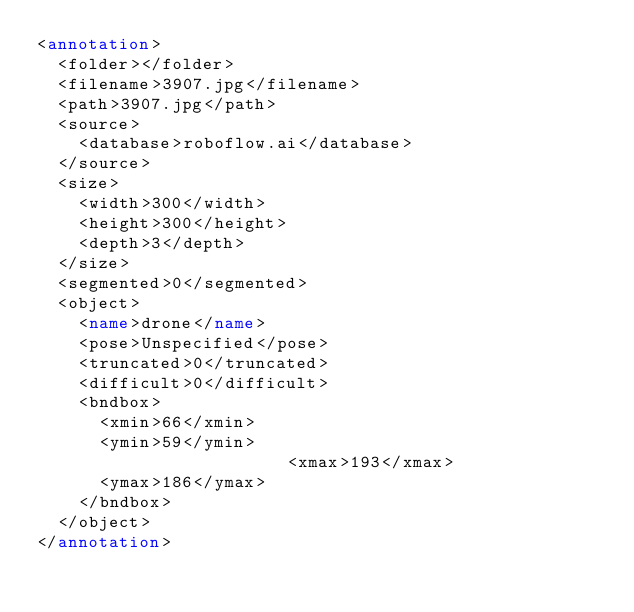<code> <loc_0><loc_0><loc_500><loc_500><_XML_><annotation>
	<folder></folder>
	<filename>3907.jpg</filename>
	<path>3907.jpg</path>
	<source>
		<database>roboflow.ai</database>
	</source>
	<size>
		<width>300</width>
		<height>300</height>
		<depth>3</depth>
	</size>
	<segmented>0</segmented>
	<object>
		<name>drone</name>
		<pose>Unspecified</pose>
		<truncated>0</truncated>
		<difficult>0</difficult>
		<bndbox>
			<xmin>66</xmin>
			<ymin>59</ymin>
                        <xmax>193</xmax>
			<ymax>186</ymax>
		</bndbox>
	</object>
</annotation>
</code> 